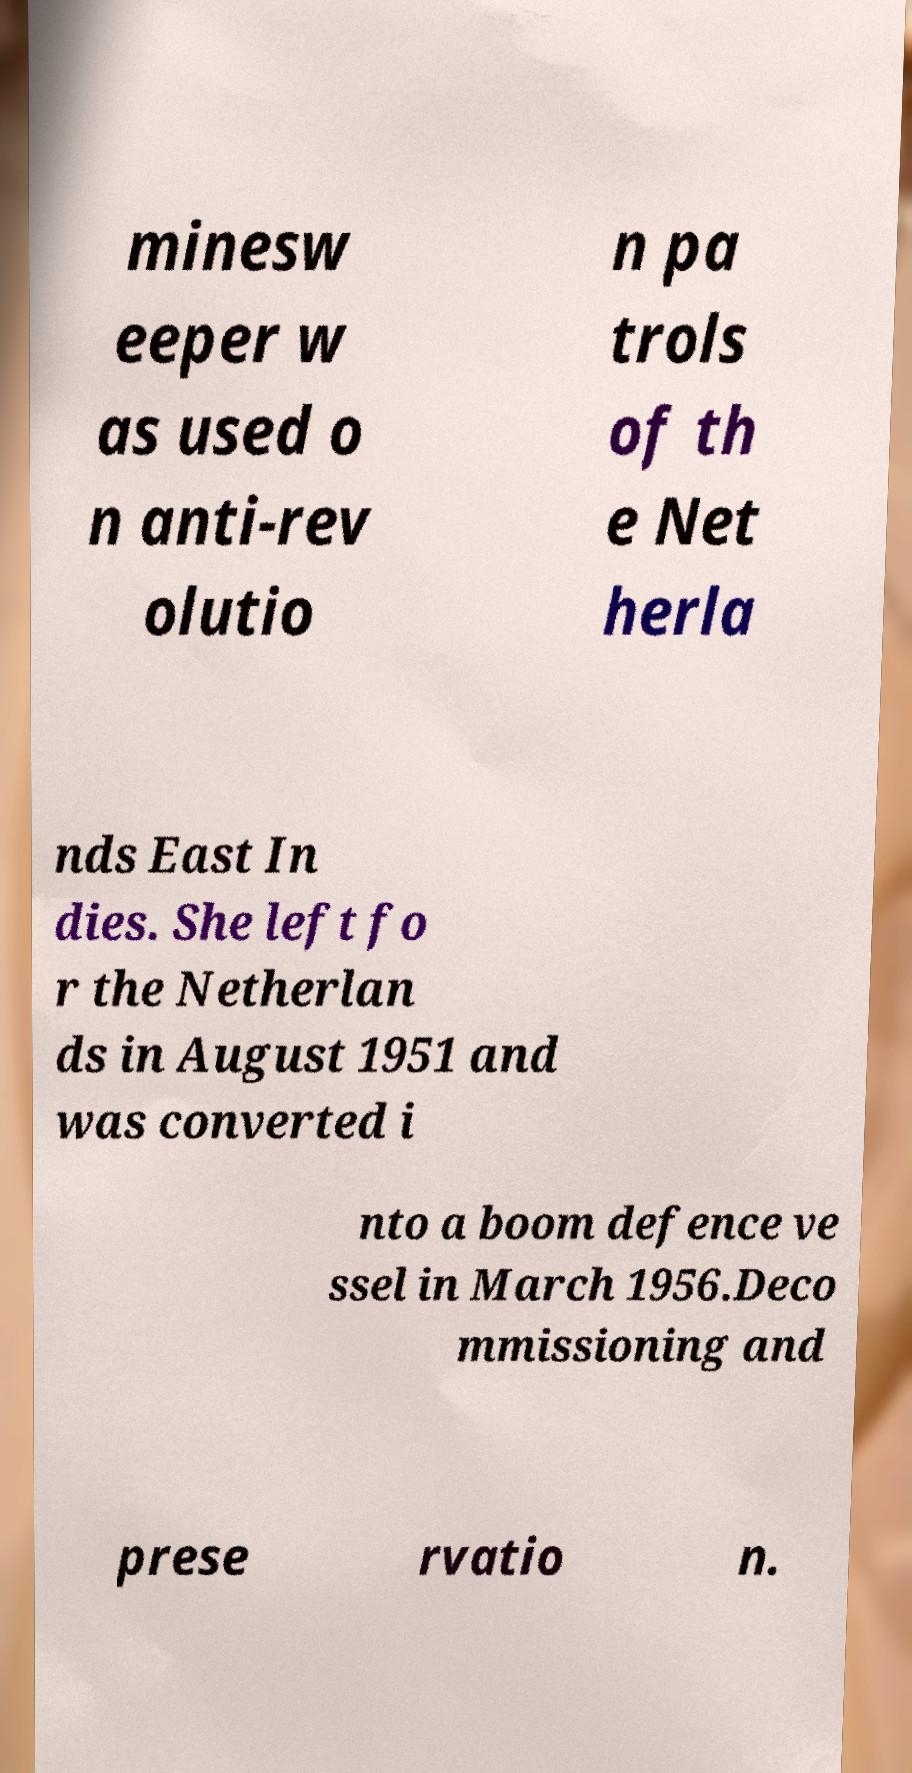What messages or text are displayed in this image? I need them in a readable, typed format. minesw eeper w as used o n anti-rev olutio n pa trols of th e Net herla nds East In dies. She left fo r the Netherlan ds in August 1951 and was converted i nto a boom defence ve ssel in March 1956.Deco mmissioning and prese rvatio n. 